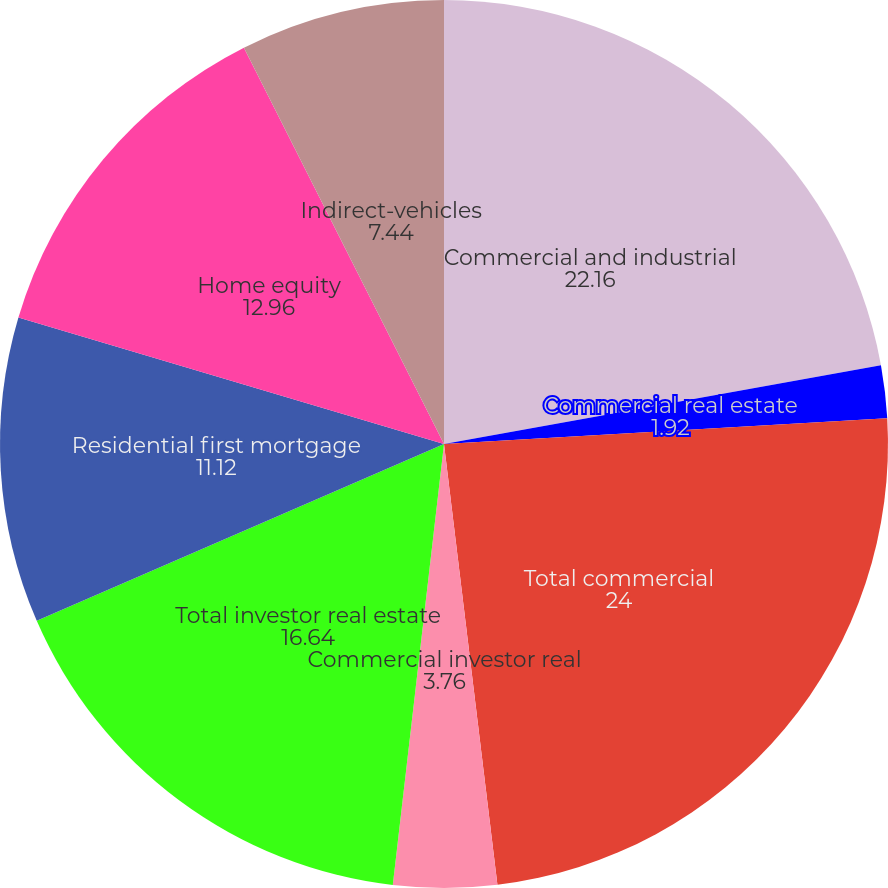<chart> <loc_0><loc_0><loc_500><loc_500><pie_chart><fcel>Commercial and industrial<fcel>Commercial real estate<fcel>Total commercial<fcel>Commercial investor real<fcel>Total investor real estate<fcel>Residential first mortgage<fcel>Home equity<fcel>Indirect-vehicles<nl><fcel>22.16%<fcel>1.92%<fcel>24.0%<fcel>3.76%<fcel>16.64%<fcel>11.12%<fcel>12.96%<fcel>7.44%<nl></chart> 